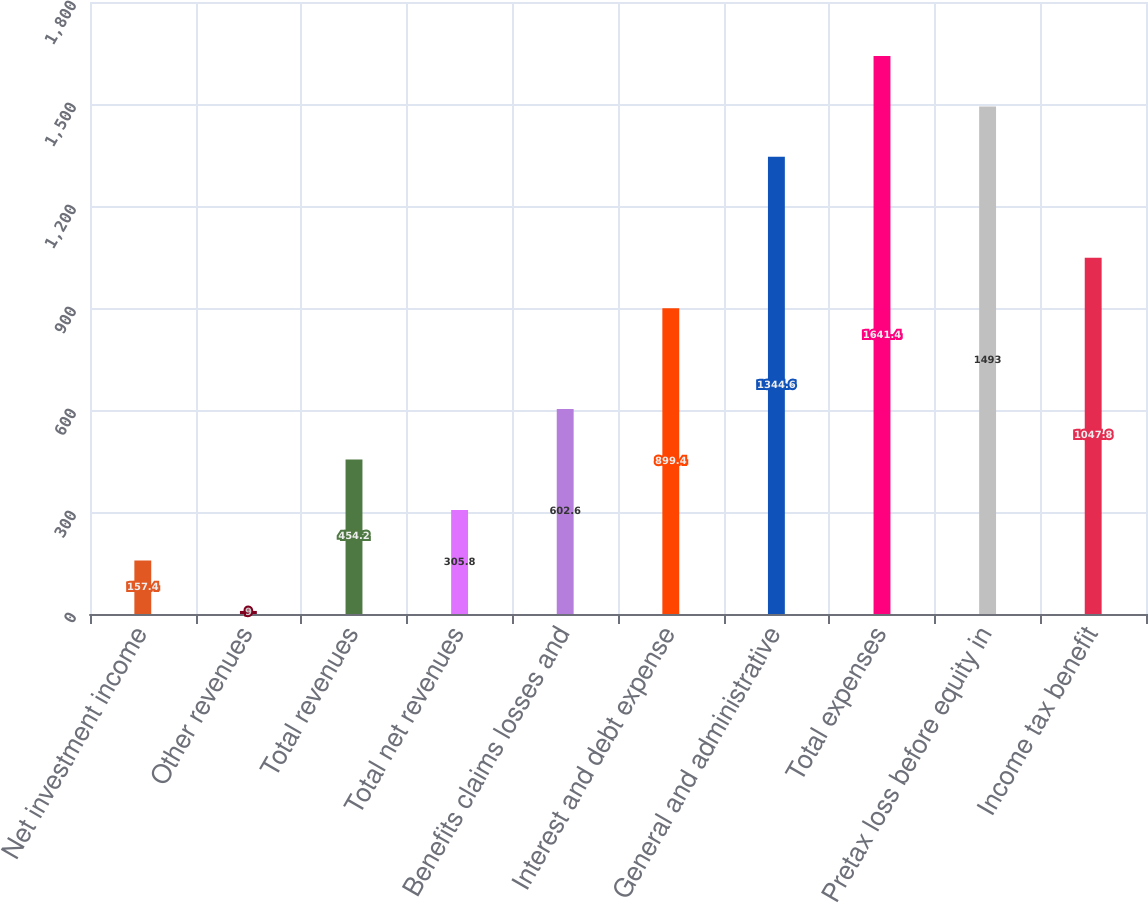Convert chart. <chart><loc_0><loc_0><loc_500><loc_500><bar_chart><fcel>Net investment income<fcel>Other revenues<fcel>Total revenues<fcel>Total net revenues<fcel>Benefits claims losses and<fcel>Interest and debt expense<fcel>General and administrative<fcel>Total expenses<fcel>Pretax loss before equity in<fcel>Income tax benefit<nl><fcel>157.4<fcel>9<fcel>454.2<fcel>305.8<fcel>602.6<fcel>899.4<fcel>1344.6<fcel>1641.4<fcel>1493<fcel>1047.8<nl></chart> 